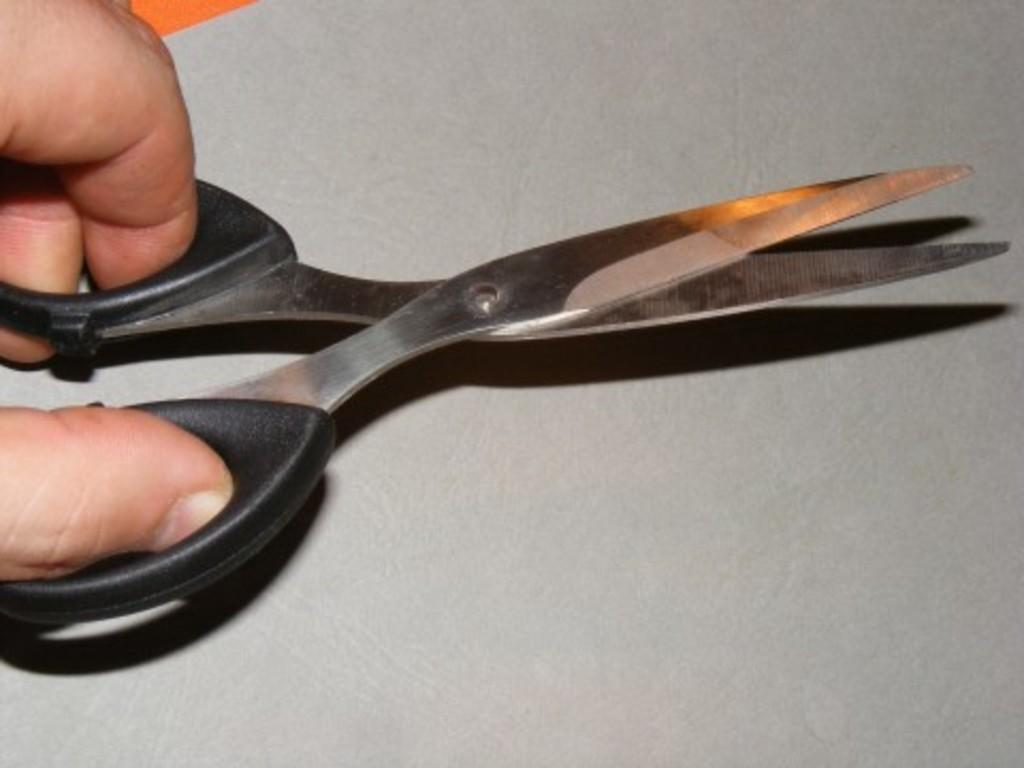What is present in the image? There is a person in the image. What is the person holding in the image? The person is holding black color scissors. What type of bag is the person using to cook in the image? There is no bag or cooking activity present in the image. 